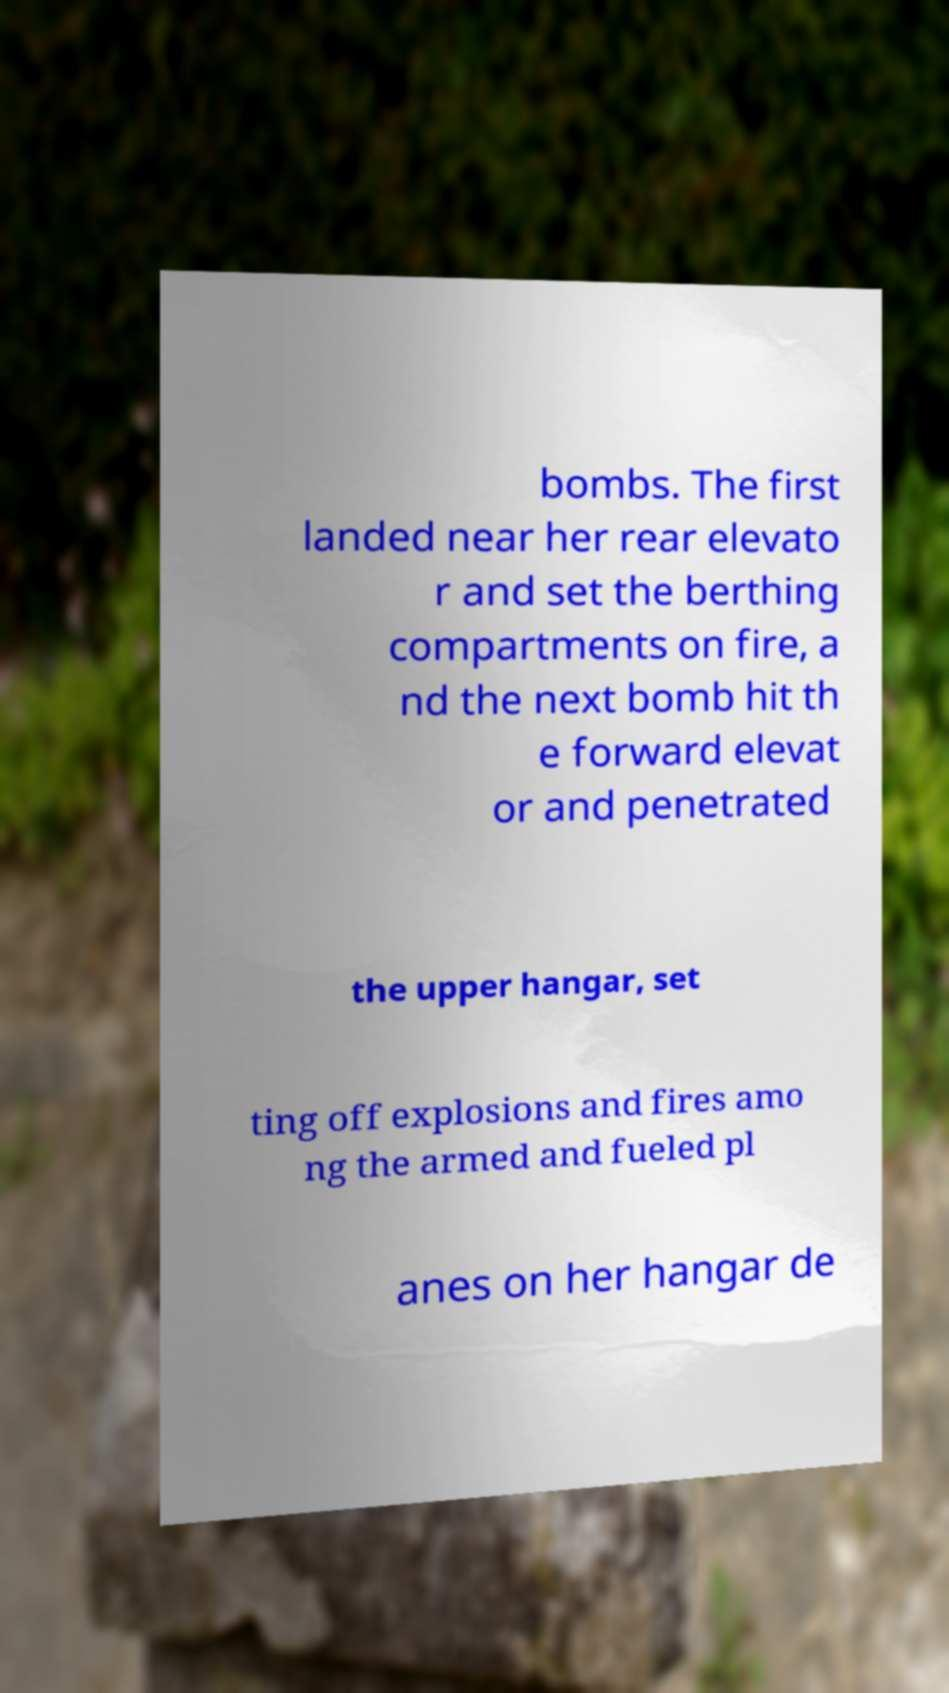There's text embedded in this image that I need extracted. Can you transcribe it verbatim? bombs. The first landed near her rear elevato r and set the berthing compartments on fire, a nd the next bomb hit th e forward elevat or and penetrated the upper hangar, set ting off explosions and fires amo ng the armed and fueled pl anes on her hangar de 